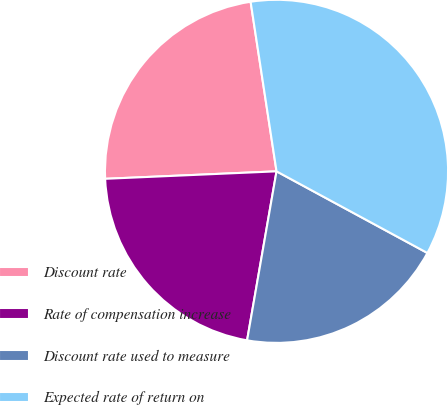<chart> <loc_0><loc_0><loc_500><loc_500><pie_chart><fcel>Discount rate<fcel>Rate of compensation increase<fcel>Discount rate used to measure<fcel>Expected rate of return on<nl><fcel>23.28%<fcel>21.56%<fcel>19.85%<fcel>35.31%<nl></chart> 